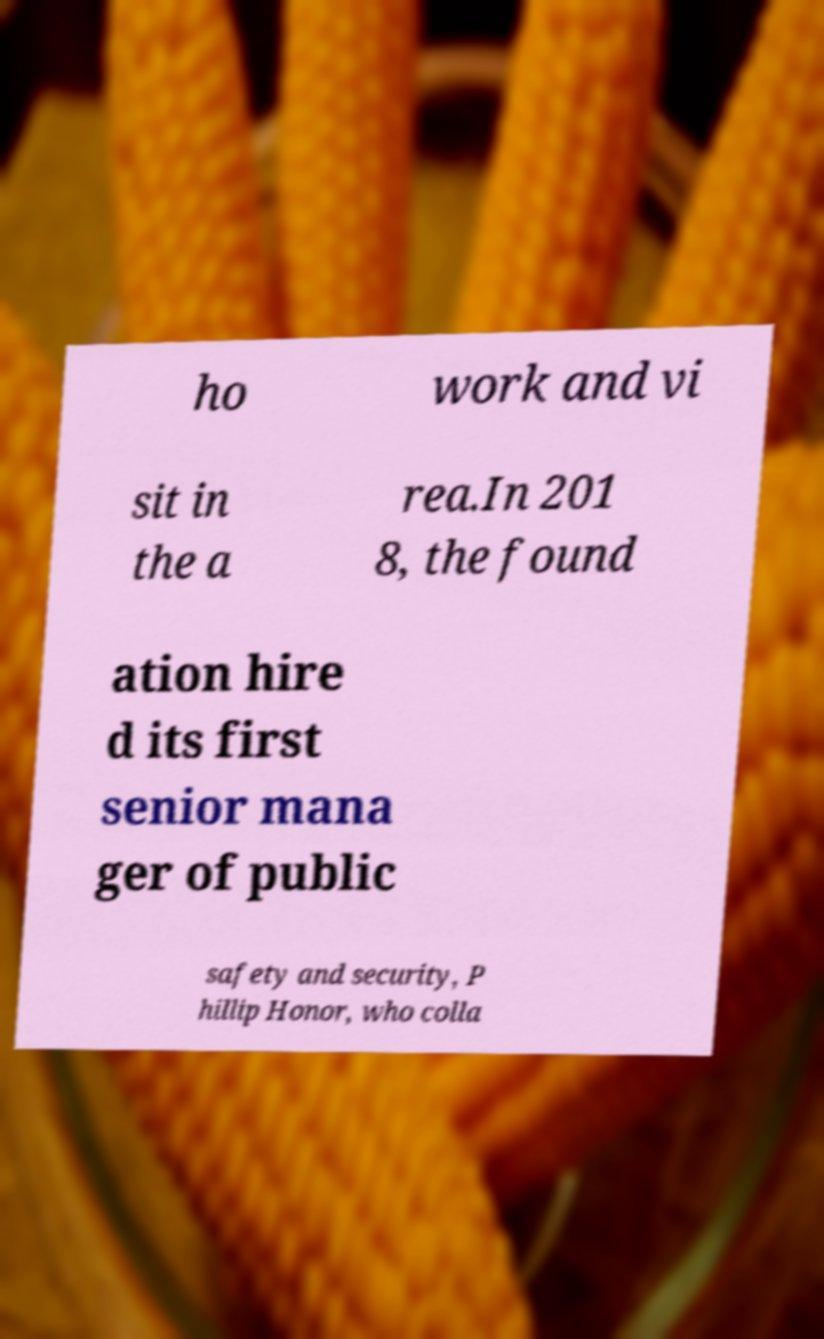Can you accurately transcribe the text from the provided image for me? ho work and vi sit in the a rea.In 201 8, the found ation hire d its first senior mana ger of public safety and security, P hillip Honor, who colla 